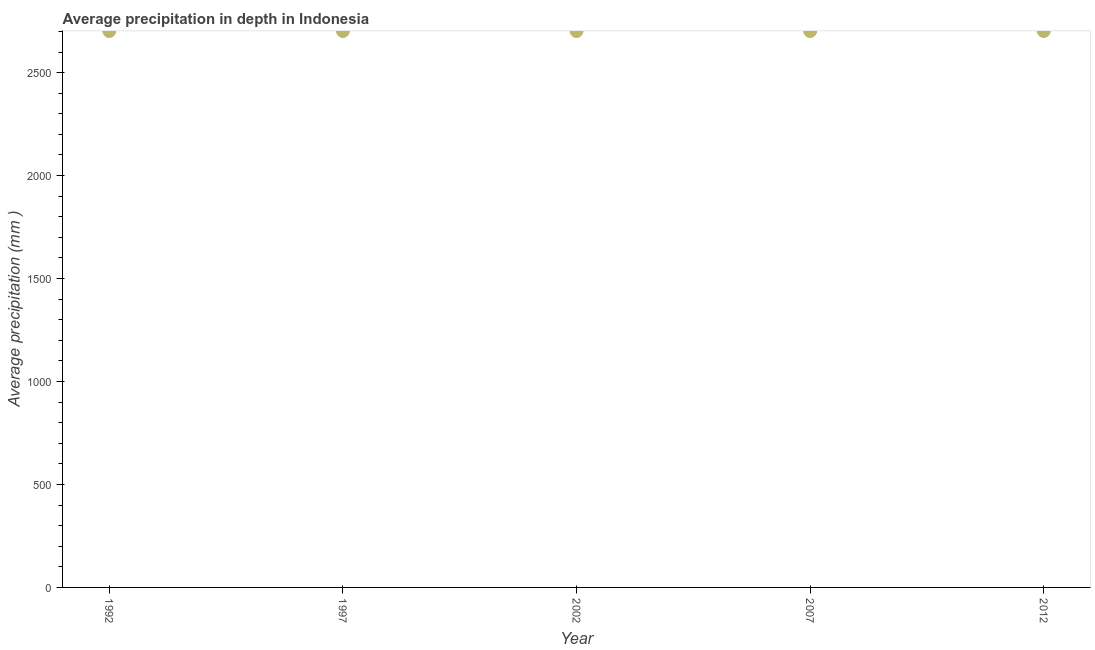What is the average precipitation in depth in 2012?
Your answer should be compact. 2702. Across all years, what is the maximum average precipitation in depth?
Your answer should be compact. 2702. Across all years, what is the minimum average precipitation in depth?
Offer a terse response. 2702. In which year was the average precipitation in depth maximum?
Keep it short and to the point. 1992. In which year was the average precipitation in depth minimum?
Offer a very short reply. 1992. What is the sum of the average precipitation in depth?
Offer a very short reply. 1.35e+04. What is the average average precipitation in depth per year?
Give a very brief answer. 2702. What is the median average precipitation in depth?
Keep it short and to the point. 2702. Do a majority of the years between 2007 and 2002 (inclusive) have average precipitation in depth greater than 1500 mm?
Offer a very short reply. No. Is the average precipitation in depth in 2002 less than that in 2012?
Your answer should be very brief. No. Is the sum of the average precipitation in depth in 1992 and 2012 greater than the maximum average precipitation in depth across all years?
Provide a short and direct response. Yes. Does the average precipitation in depth monotonically increase over the years?
Provide a short and direct response. No. What is the difference between two consecutive major ticks on the Y-axis?
Your answer should be compact. 500. Does the graph contain any zero values?
Make the answer very short. No. What is the title of the graph?
Offer a very short reply. Average precipitation in depth in Indonesia. What is the label or title of the X-axis?
Make the answer very short. Year. What is the label or title of the Y-axis?
Provide a short and direct response. Average precipitation (mm ). What is the Average precipitation (mm ) in 1992?
Your answer should be compact. 2702. What is the Average precipitation (mm ) in 1997?
Give a very brief answer. 2702. What is the Average precipitation (mm ) in 2002?
Ensure brevity in your answer.  2702. What is the Average precipitation (mm ) in 2007?
Keep it short and to the point. 2702. What is the Average precipitation (mm ) in 2012?
Your answer should be compact. 2702. What is the difference between the Average precipitation (mm ) in 1992 and 1997?
Ensure brevity in your answer.  0. What is the difference between the Average precipitation (mm ) in 1992 and 2007?
Give a very brief answer. 0. What is the difference between the Average precipitation (mm ) in 2002 and 2007?
Your answer should be compact. 0. What is the ratio of the Average precipitation (mm ) in 1992 to that in 1997?
Provide a succinct answer. 1. What is the ratio of the Average precipitation (mm ) in 1992 to that in 2002?
Your response must be concise. 1. What is the ratio of the Average precipitation (mm ) in 1992 to that in 2007?
Provide a short and direct response. 1. What is the ratio of the Average precipitation (mm ) in 1992 to that in 2012?
Your response must be concise. 1. What is the ratio of the Average precipitation (mm ) in 1997 to that in 2012?
Offer a terse response. 1. What is the ratio of the Average precipitation (mm ) in 2002 to that in 2012?
Ensure brevity in your answer.  1. 